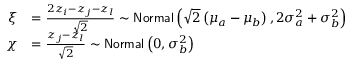<formula> <loc_0><loc_0><loc_500><loc_500>\begin{array} { r l } { \xi } & { = \frac { 2 z _ { i } - z _ { j } - z _ { l } } { \sqrt { 2 } } \sim N o r m a l \left ( \sqrt { 2 } \left ( \mu _ { a } - \mu _ { b } \right ) , 2 \sigma _ { a } ^ { 2 } + \sigma _ { b } ^ { 2 } \right ) } \\ { \chi } & { = \frac { z _ { j } - z _ { l } } { \sqrt { 2 } } \sim N o r m a l \left ( 0 , \sigma _ { b } ^ { 2 } \right ) } \end{array}</formula> 